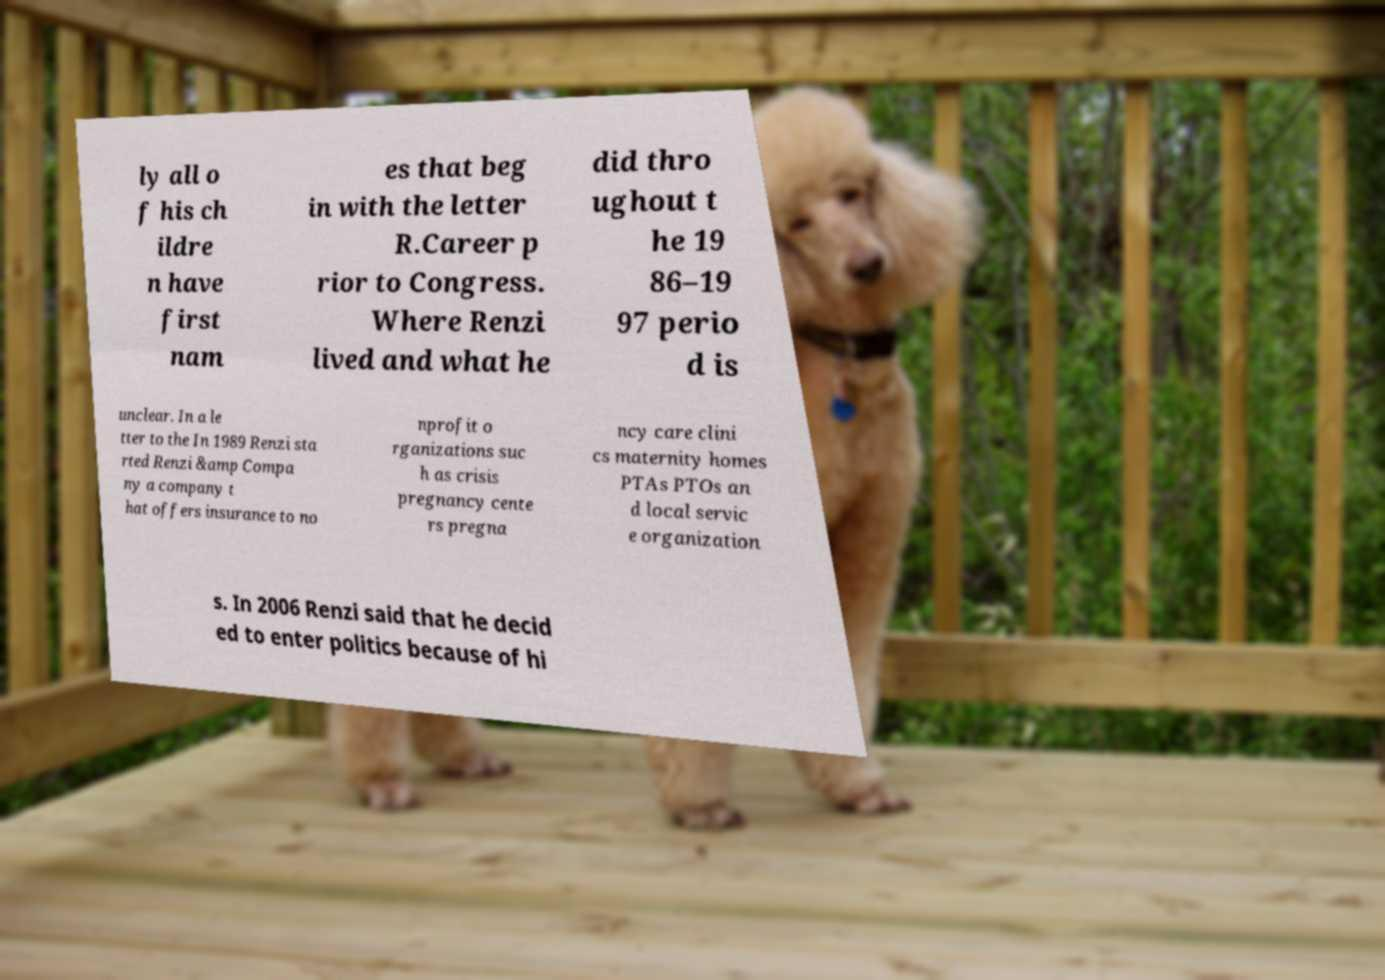There's text embedded in this image that I need extracted. Can you transcribe it verbatim? ly all o f his ch ildre n have first nam es that beg in with the letter R.Career p rior to Congress. Where Renzi lived and what he did thro ughout t he 19 86–19 97 perio d is unclear. In a le tter to the In 1989 Renzi sta rted Renzi &amp Compa ny a company t hat offers insurance to no nprofit o rganizations suc h as crisis pregnancy cente rs pregna ncy care clini cs maternity homes PTAs PTOs an d local servic e organization s. In 2006 Renzi said that he decid ed to enter politics because of hi 